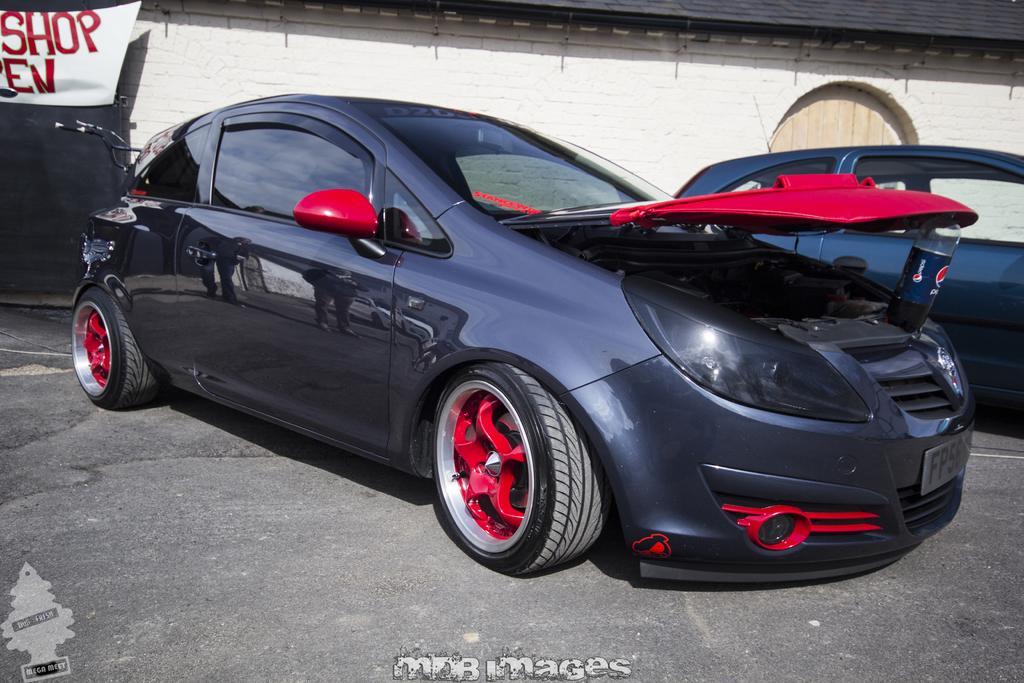Describe this image in one or two sentences. In this image there are two cars and a bicycle on the path , and there is a wall, door, banner and there are watermarks on the image. 